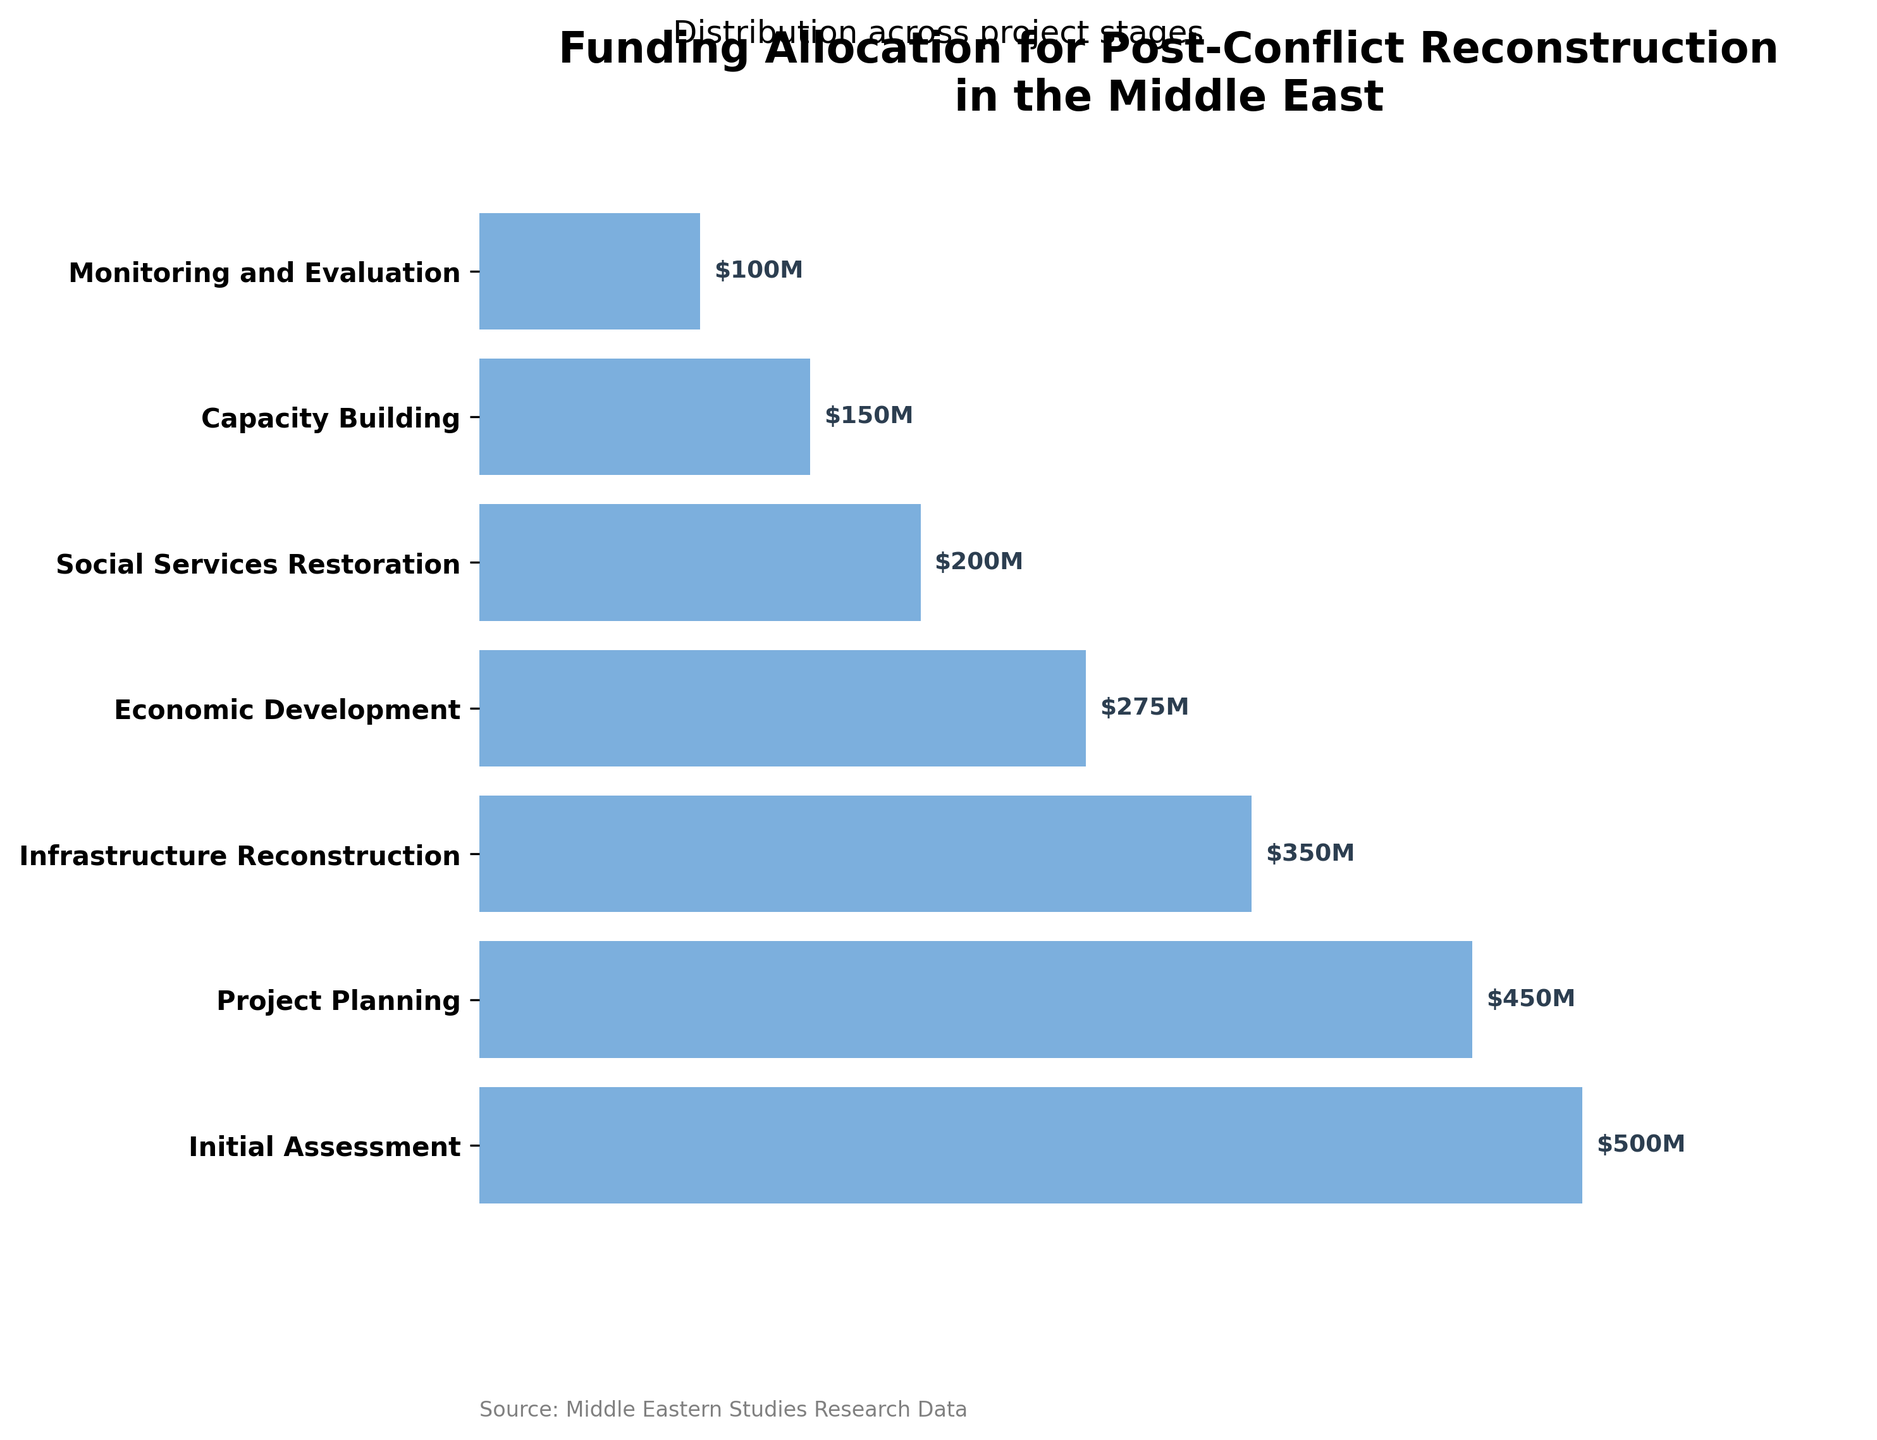What's the initial funding allocation for the Initial Assessment stage? The figure shows that the Initial Assessment stage has the highest funding allocation. By looking at the data bar for this stage, we see the value attached.
Answer: $500M Which stage receives the least amount of funding? The stage with the smallest bar in the figure represents the lowest funding allocation, which is also labeled.
Answer: Monitoring and Evaluation What is the difference in funding between Project Planning and Infrastructure Reconstruction? Locate the funding amounts for both stages (Project Planning: $450M, Infrastructure Reconstruction: $350M) and subtract the latter from the former.
Answer: $100M How many stages are shown in the funnel chart? Count the number of distinct stages listed on the y-axis of the figure.
Answer: 7 Which stage receives more funding, Economic Development or Social Services Restoration? Compare the labeled funding allocations for Economic Development ($275M) and Social Services Restoration ($200M).
Answer: Economic Development What is the total funding allocated across all stages? Add the funding values for all stages: 500 + 450 + 350 + 275 + 200 + 150 + 100.
Answer: $2025M What percentage of the total funding is allocated to Capacity Building? Divide the funding for Capacity Building ($150M) by the total funding ($2025M) and multiply by 100.
Answer: 7.41% Is the funding allocation for Social Services Restoration more than or less than half of the initial funding for Initial Assessment? Compare half of the funding for Initial Assessment ($500M / 2 = $250M) with the funding for Social Services Restoration ($200M).
Answer: Less than half By how much does the funding allocation decrease from the Initial Assessment stage to the Project Planning stage? Subtract the funding for Project Planning ($450M) from that of Initial Assessment ($500M).
Answer: $50M Out of Infrastructure Reconstruction and Capacity Building, which receives the greater amount of funding and by how much? Compare the funding amounts for Infrastructure Reconstruction ($350M) and Capacity Building ($150M), then subtract the lower value from the higher one.
Answer: Infrastructure Reconstruction, by $200M 